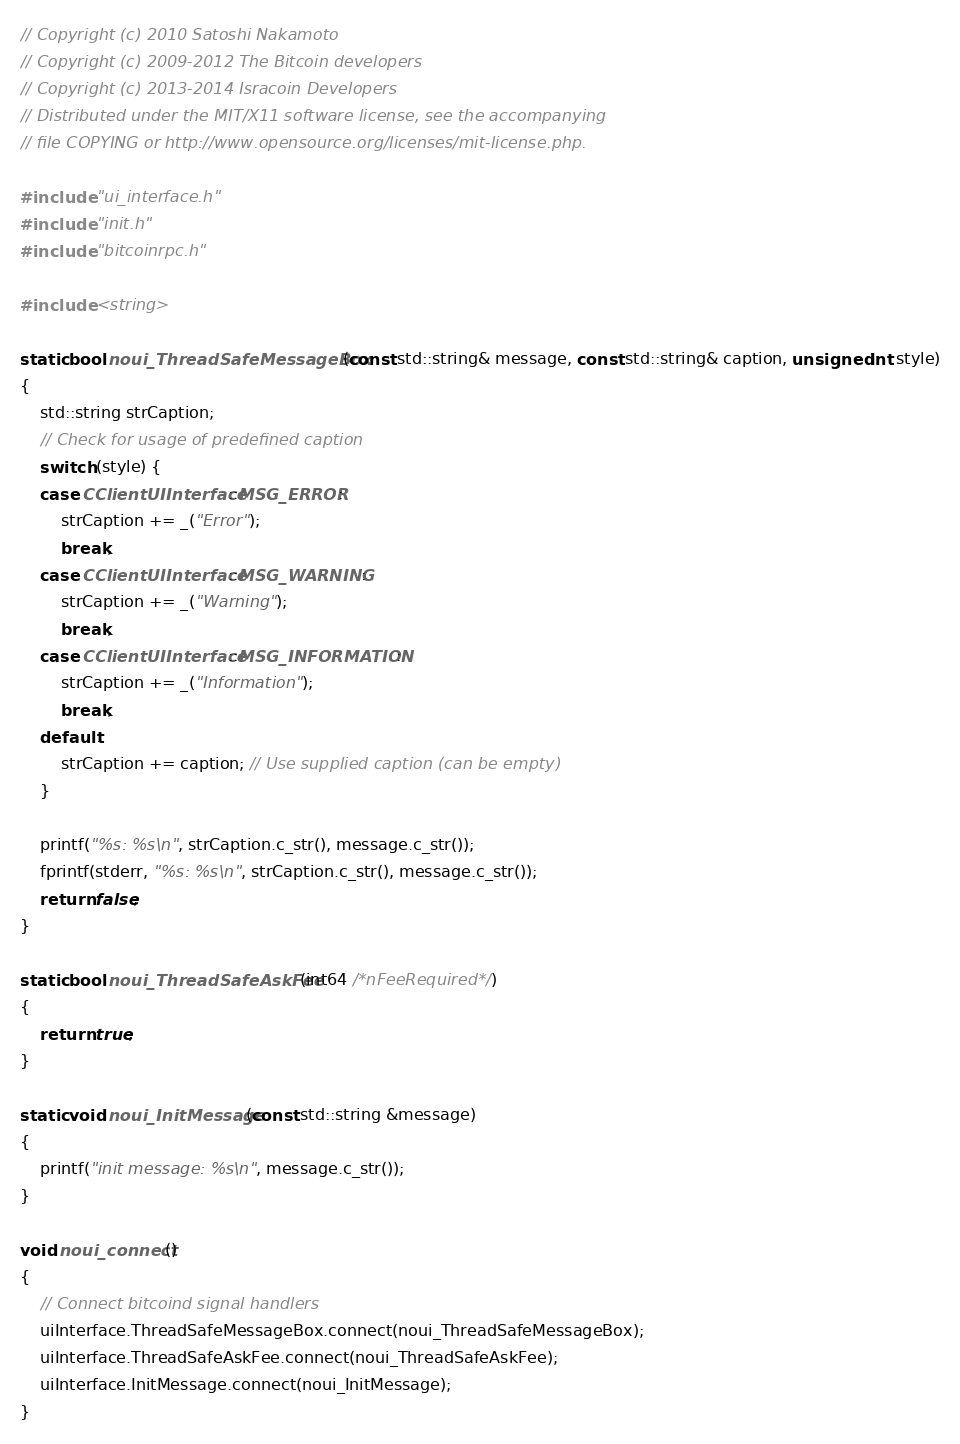Convert code to text. <code><loc_0><loc_0><loc_500><loc_500><_C++_>// Copyright (c) 2010 Satoshi Nakamoto
// Copyright (c) 2009-2012 The Bitcoin developers
// Copyright (c) 2013-2014 Isracoin Developers
// Distributed under the MIT/X11 software license, see the accompanying
// file COPYING or http://www.opensource.org/licenses/mit-license.php.

#include "ui_interface.h"
#include "init.h"
#include "bitcoinrpc.h"

#include <string>

static bool noui_ThreadSafeMessageBox(const std::string& message, const std::string& caption, unsigned int style)
{
    std::string strCaption;
    // Check for usage of predefined caption
    switch (style) {
    case CClientUIInterface::MSG_ERROR:
        strCaption += _("Error");
        break;
    case CClientUIInterface::MSG_WARNING:
        strCaption += _("Warning");
        break;
    case CClientUIInterface::MSG_INFORMATION:
        strCaption += _("Information");
        break;
    default:
        strCaption += caption; // Use supplied caption (can be empty)
    }

    printf("%s: %s\n", strCaption.c_str(), message.c_str());
    fprintf(stderr, "%s: %s\n", strCaption.c_str(), message.c_str());
    return false;
}

static bool noui_ThreadSafeAskFee(int64 /*nFeeRequired*/)
{
    return true;
}

static void noui_InitMessage(const std::string &message)
{
    printf("init message: %s\n", message.c_str());
}

void noui_connect()
{
    // Connect bitcoind signal handlers
    uiInterface.ThreadSafeMessageBox.connect(noui_ThreadSafeMessageBox);
    uiInterface.ThreadSafeAskFee.connect(noui_ThreadSafeAskFee);
    uiInterface.InitMessage.connect(noui_InitMessage);
}
</code> 